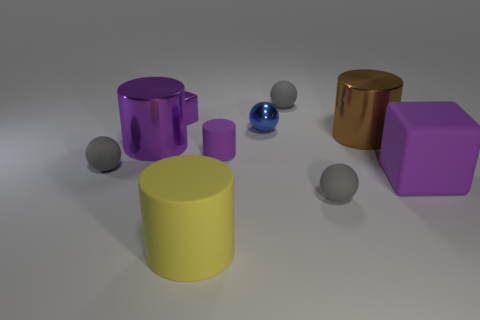Subtract all gray balls. How many were subtracted if there are1gray balls left? 2 Subtract all brown cylinders. How many gray balls are left? 3 Subtract all spheres. How many objects are left? 6 Subtract 1 brown cylinders. How many objects are left? 9 Subtract all small purple rubber cylinders. Subtract all rubber cubes. How many objects are left? 8 Add 7 brown cylinders. How many brown cylinders are left? 8 Add 9 red spheres. How many red spheres exist? 9 